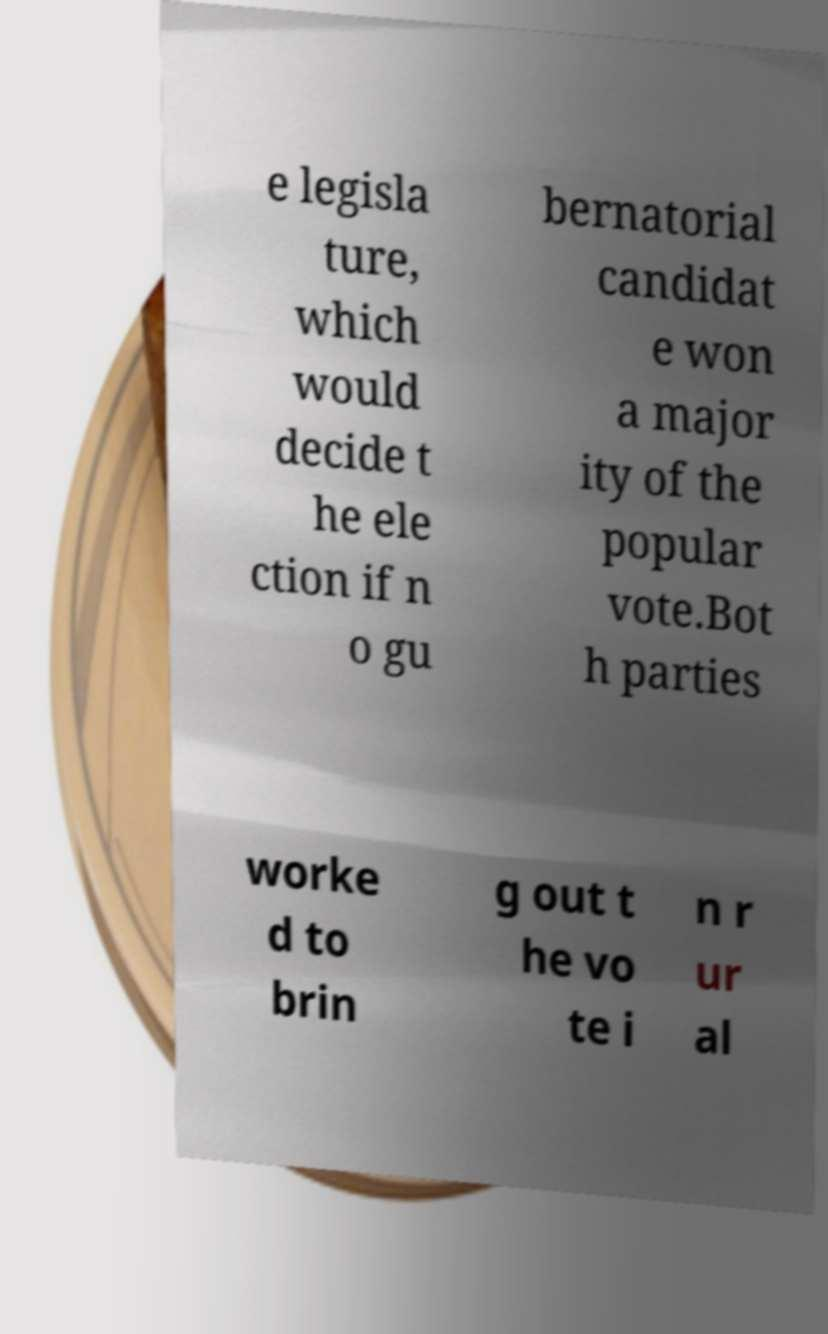For documentation purposes, I need the text within this image transcribed. Could you provide that? e legisla ture, which would decide t he ele ction if n o gu bernatorial candidat e won a major ity of the popular vote.Bot h parties worke d to brin g out t he vo te i n r ur al 